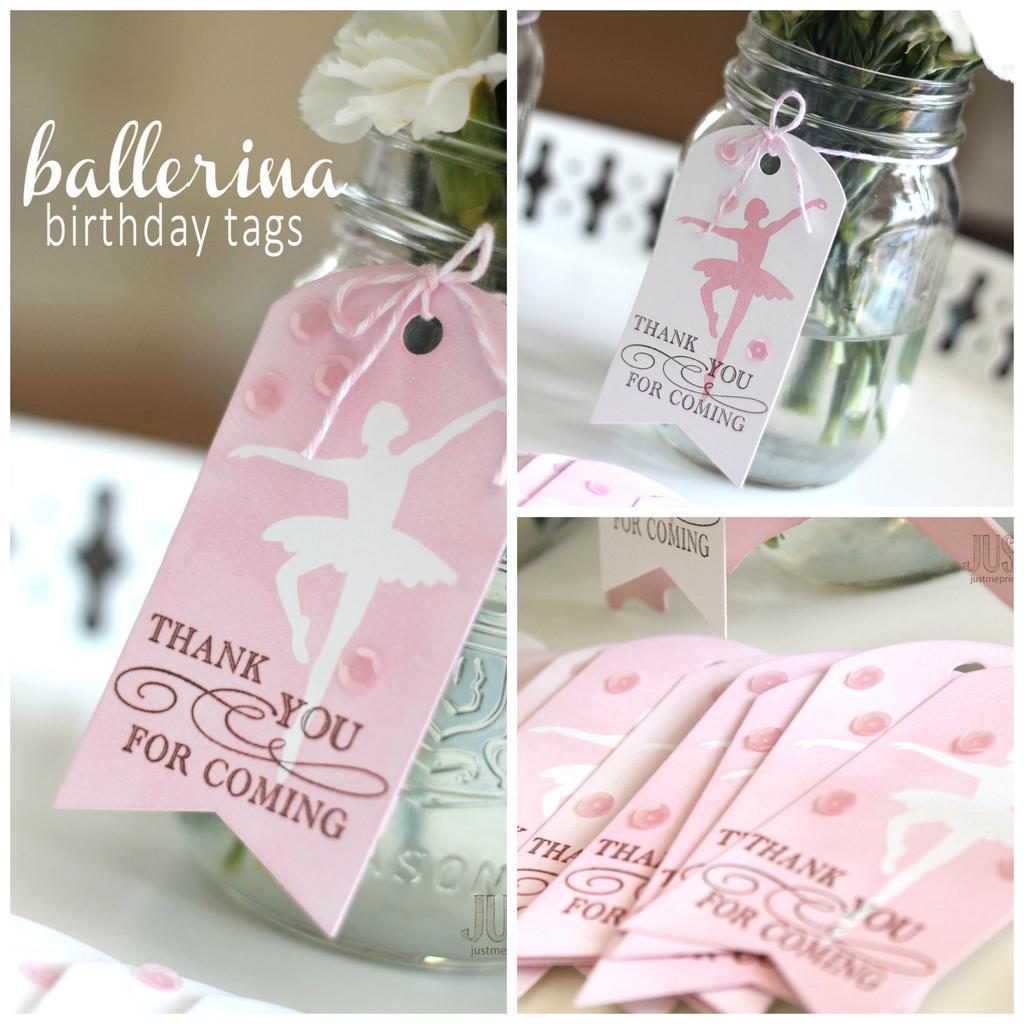In one or two sentences, can you explain what this image depicts? In the image we can see jar,in jar there is a flower. And it is tagged with one paper and written as "Thank Q For Coming". 